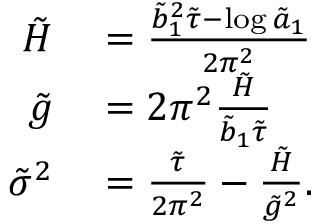Convert formula to latex. <formula><loc_0><loc_0><loc_500><loc_500>\begin{array} { r l } { \tilde { H } } & = \frac { \tilde { b } _ { 1 } ^ { 2 } \tilde { \tau } - \log \tilde { a } _ { 1 } } { 2 \pi ^ { 2 } } } \\ { \tilde { g } } & = 2 \pi ^ { 2 } \frac { \tilde { H } } { \tilde { b } _ { 1 } \tilde { \tau } } } \\ { \tilde { \sigma } ^ { 2 } } & = \frac { \tilde { \tau } } { 2 \pi ^ { 2 } } - \frac { \tilde { H } } { \tilde { g } ^ { 2 } } . } \end{array}</formula> 